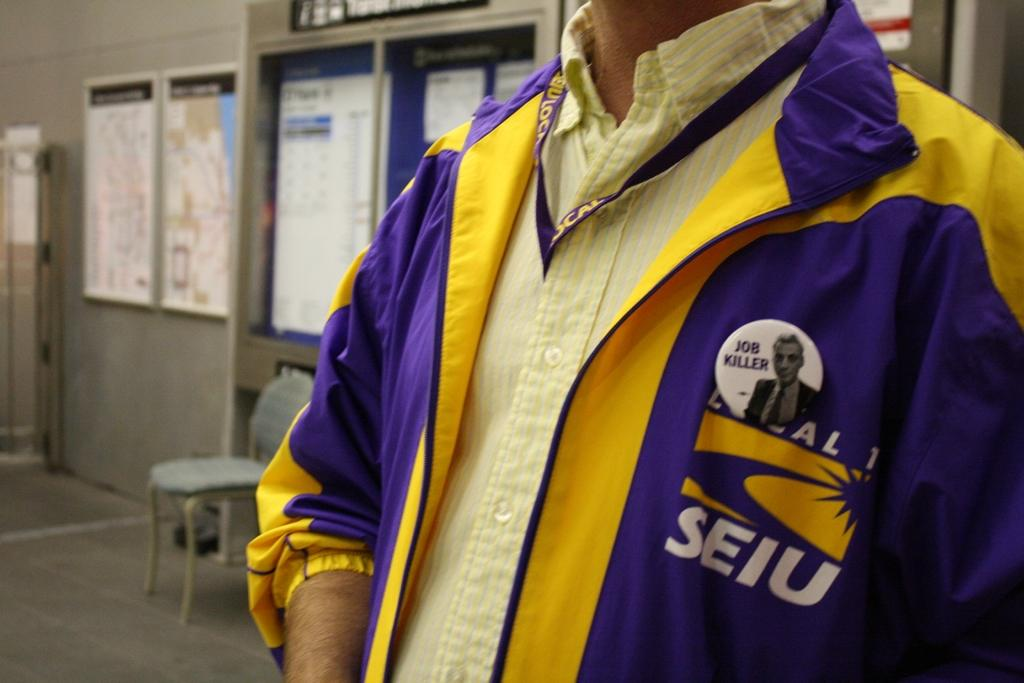<image>
Render a clear and concise summary of the photo. Man wearing a purple jacket that says "SEIU" on it. 